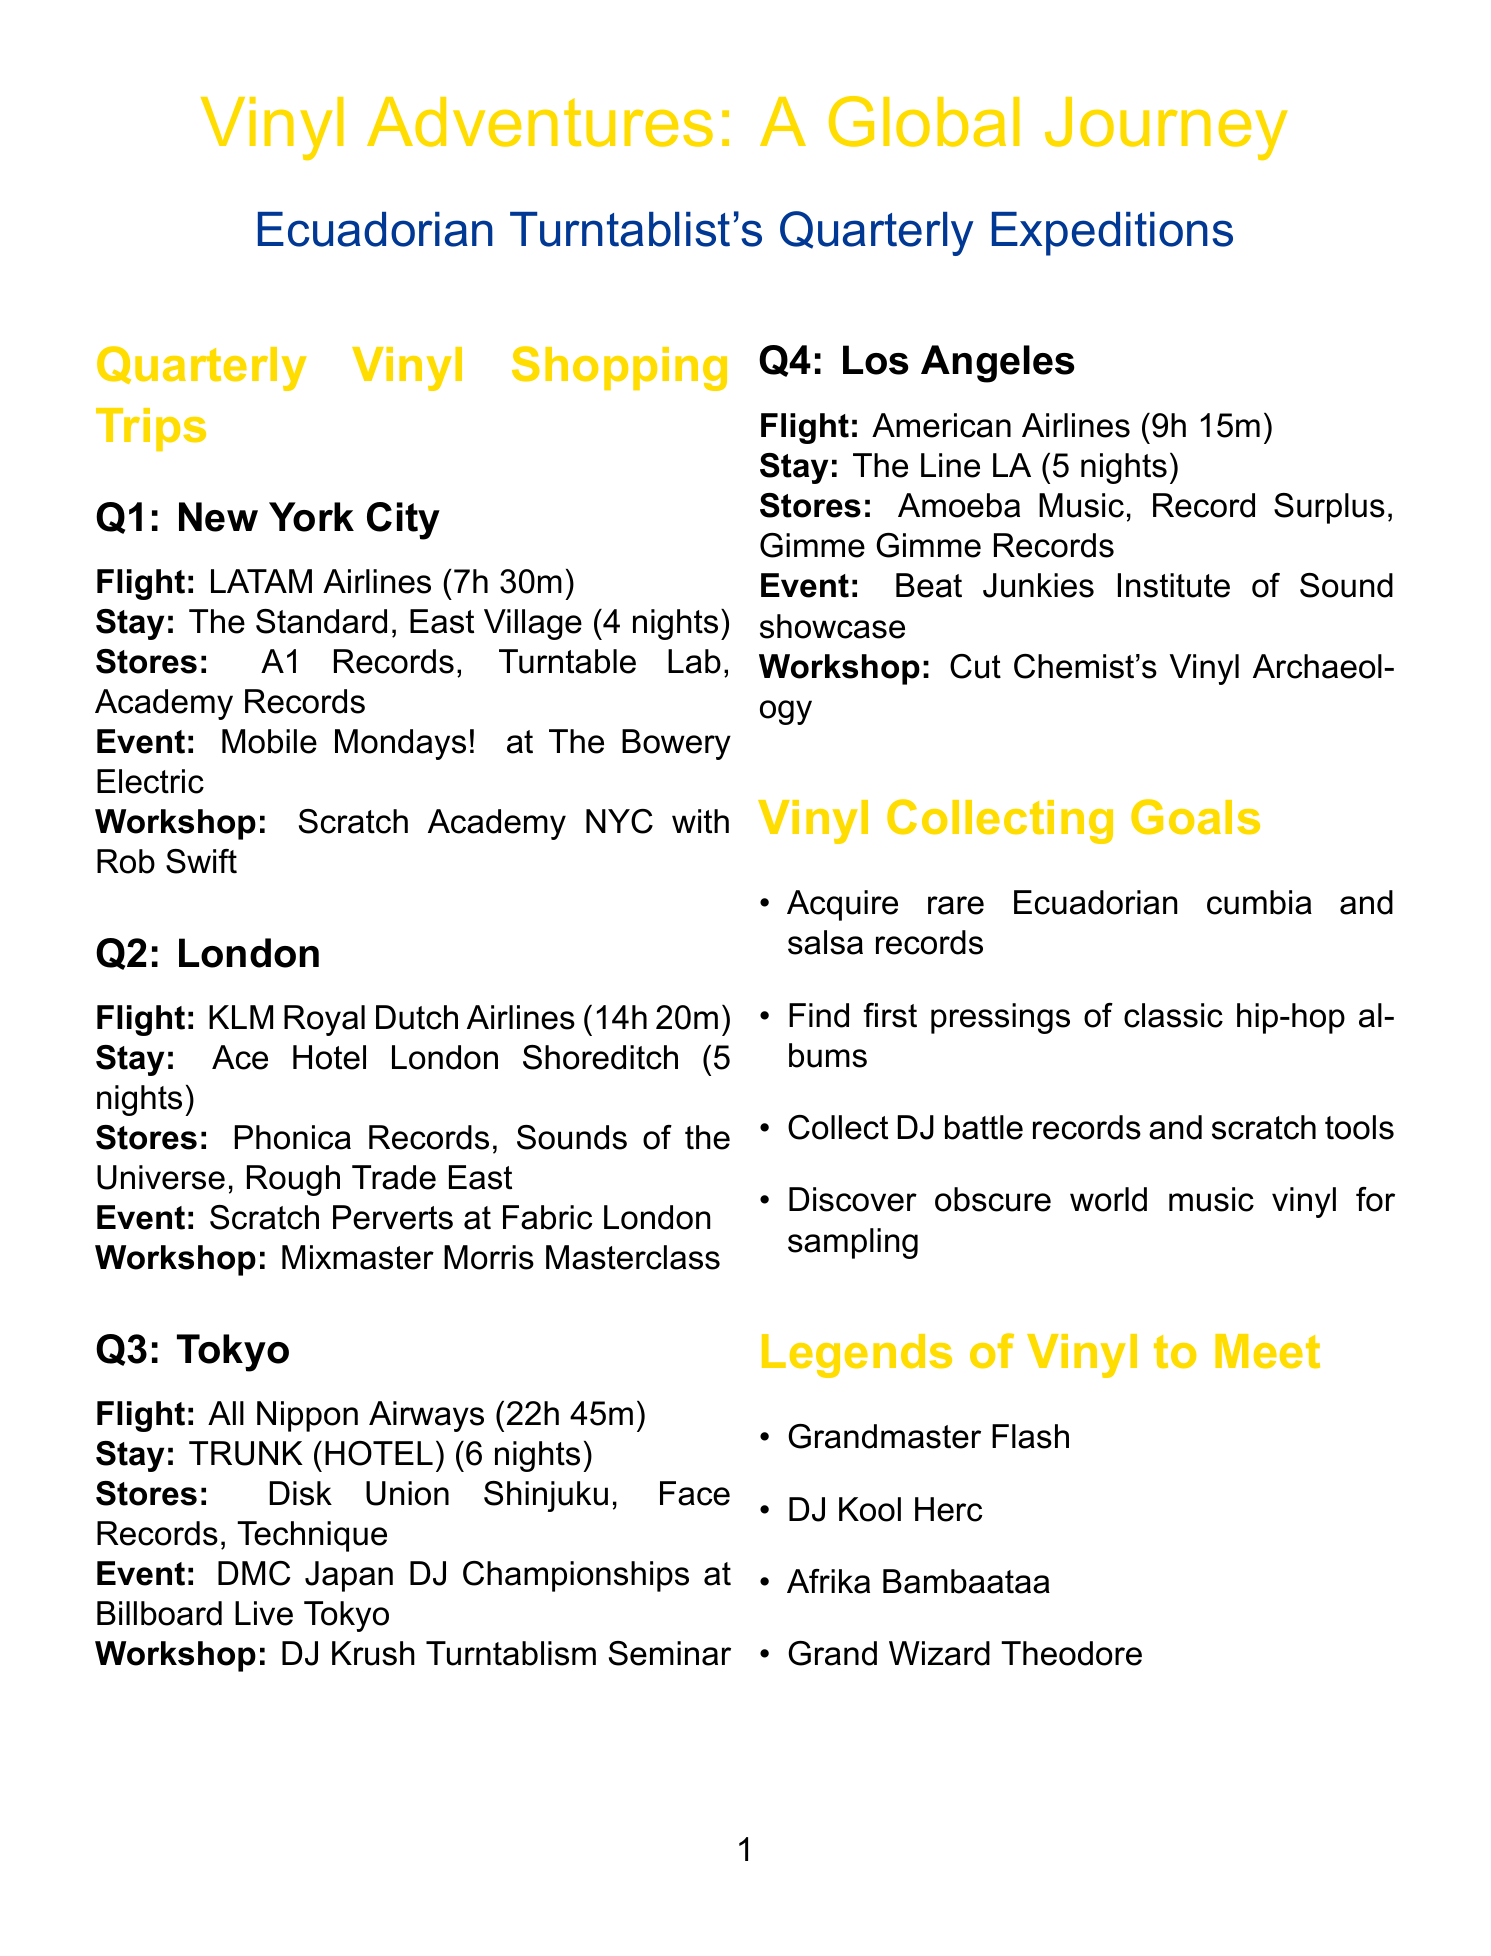What is the destination for Q2? The document specifies that Q2's destination is London.
Answer: London How many nights will you stay in Tokyo? The document indicates that the accommodation in Tokyo is for 6 nights.
Answer: 6 nights What is the name of the workshop in New York City? The document states that the workshop in New York City is called Scratch Academy NYC.
Answer: Scratch Academy NYC Which airline is used for the flight to Los Angeles? The document details that American Airlines is the airline for the flight to Los Angeles.
Answer: American Airlines What is one of the vinyl collecting goals? One of the vinyl collecting goals mentioned is to acquire rare Ecuadorian cumbia and salsa records.
Answer: Acquire rare Ecuadorian cumbia and salsa records How long is the flight duration to London? The document specifies that the flight duration to London is 14 hours and 20 minutes with a layover.
Answer: 14h 20m (with layover) What is the name of the accommodation in Los Angeles? The document states that the accommodation in Los Angeles is called The Line LA.
Answer: The Line LA Who is the instructor for the workshop in Tokyo? The document indicates that DJ Krush is the instructor for the workshop in Tokyo.
Answer: DJ Krush 